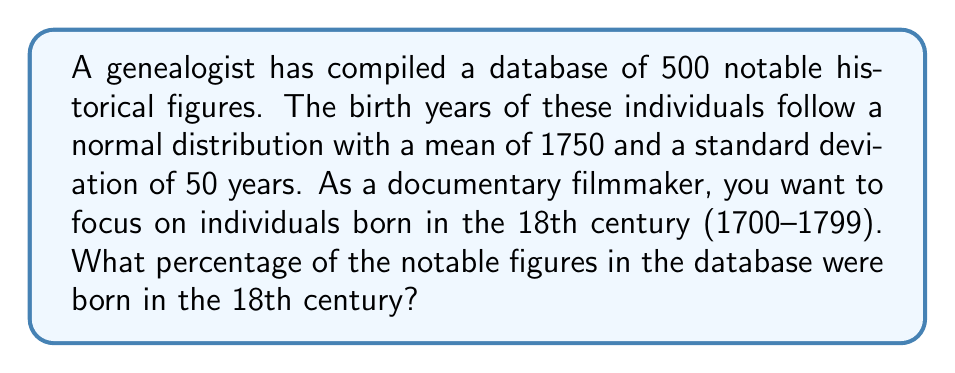What is the answer to this math problem? To solve this problem, we need to use the properties of the normal distribution and the z-score formula.

Step 1: Identify the relevant z-scores
For the 18th century:
Lower bound: 1700
Upper bound: 1799

Step 2: Calculate the z-scores for these bounds
z-score formula: $z = \frac{x - \mu}{\sigma}$

Where:
$x$ is the value of interest
$\mu$ is the mean (1750)
$\sigma$ is the standard deviation (50)

For 1700: $z_1 = \frac{1700 - 1750}{50} = -1$
For 1799: $z_2 = \frac{1799 - 1750}{50} = 0.98$

Step 3: Use a standard normal distribution table or calculator to find the area between these z-scores

The area between $z = -1$ and $z = 0.98$ represents the proportion of individuals born in the 18th century.

Using a calculator or standard normal table:
P($-1 < z < 0.98$) = P($z < 0.98$) - P($z < -1$)
                   = 0.8365 - 0.1587
                   = 0.6778

Step 4: Convert the proportion to a percentage
0.6778 * 100 = 67.78%

Therefore, approximately 67.78% of the notable figures in the database were born in the 18th century.
Answer: 67.78% 